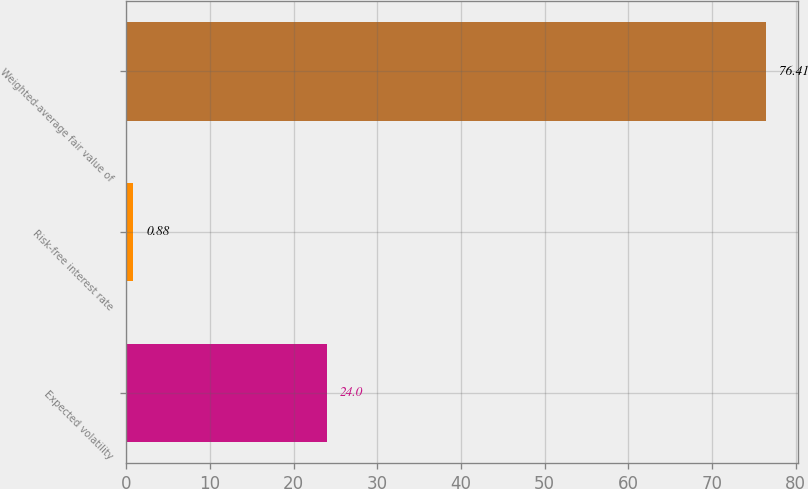<chart> <loc_0><loc_0><loc_500><loc_500><bar_chart><fcel>Expected volatility<fcel>Risk-free interest rate<fcel>Weighted-average fair value of<nl><fcel>24<fcel>0.88<fcel>76.41<nl></chart> 